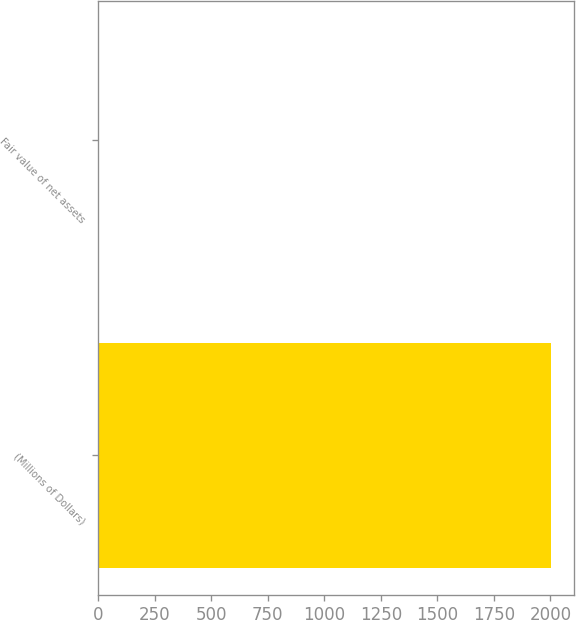<chart> <loc_0><loc_0><loc_500><loc_500><bar_chart><fcel>(Millions of Dollars)<fcel>Fair value of net assets<nl><fcel>2003<fcel>5<nl></chart> 